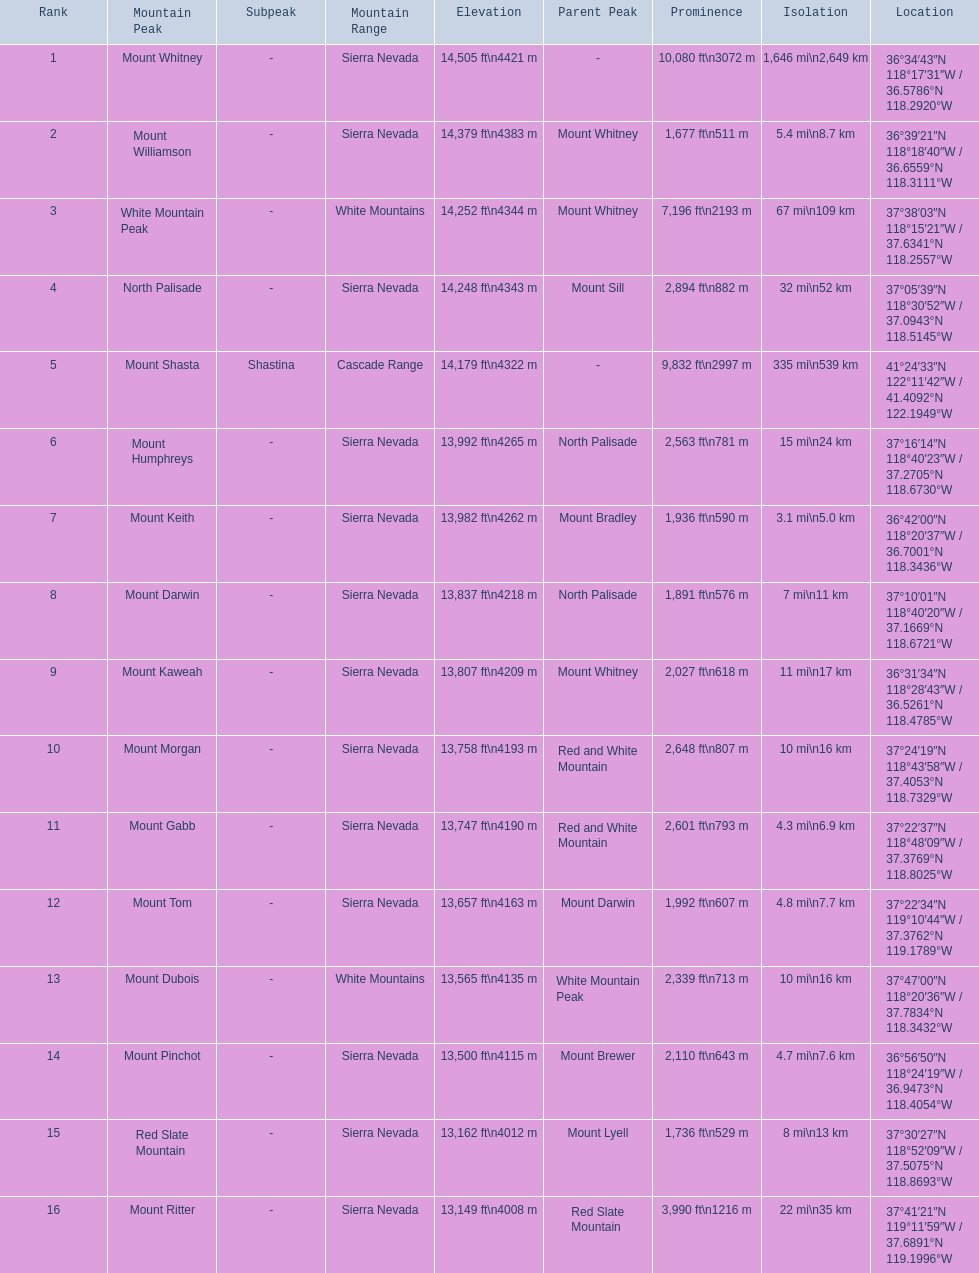What are the heights of the peaks? 14,505 ft\n4421 m, 14,379 ft\n4383 m, 14,252 ft\n4344 m, 14,248 ft\n4343 m, 14,179 ft\n4322 m, 13,992 ft\n4265 m, 13,982 ft\n4262 m, 13,837 ft\n4218 m, 13,807 ft\n4209 m, 13,758 ft\n4193 m, 13,747 ft\n4190 m, 13,657 ft\n4163 m, 13,565 ft\n4135 m, 13,500 ft\n4115 m, 13,162 ft\n4012 m, 13,149 ft\n4008 m. Which of these heights is tallest? 14,505 ft\n4421 m. What peak is 14,505 feet? Mount Whitney. 